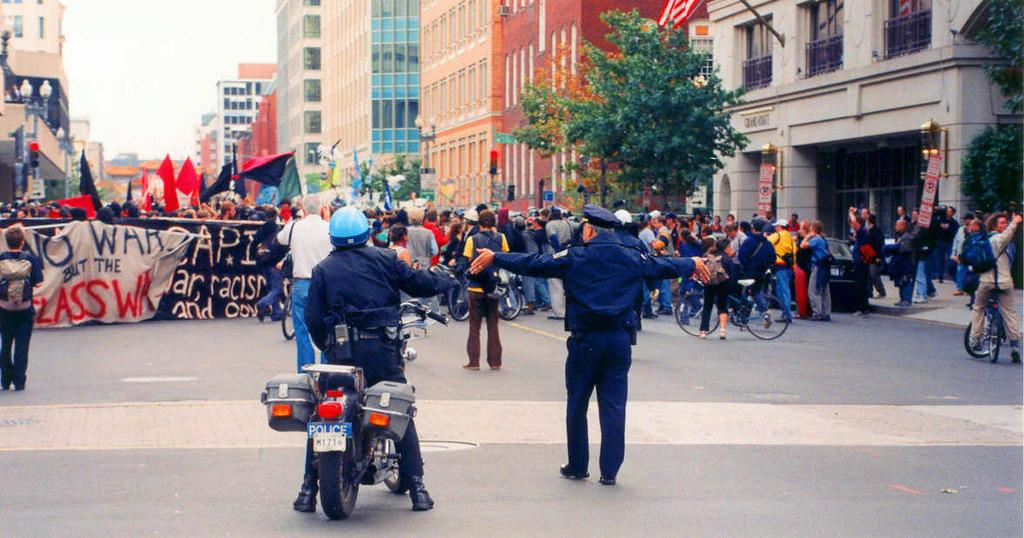What is: What is happening in the image? There are many people protesting in the image. What are some of the protesters holding? Some of the protesters are holding banners and flags. What type of structures can be seen in the background? There are buildings with glass windows in the image. What type of vegetation is present in the image? There are trees in the image. What is the condition of the sky in the image? The sky is clear in the image. What type of substance is being sold by the crowd in the image? There is no indication in the image that a crowd is selling any substance; the image depicts a protest. Can you describe the bedroom where the protesters are gathering in the image? There is no bedroom present in the image; the protesters are outside, in front of buildings with glass windows. 